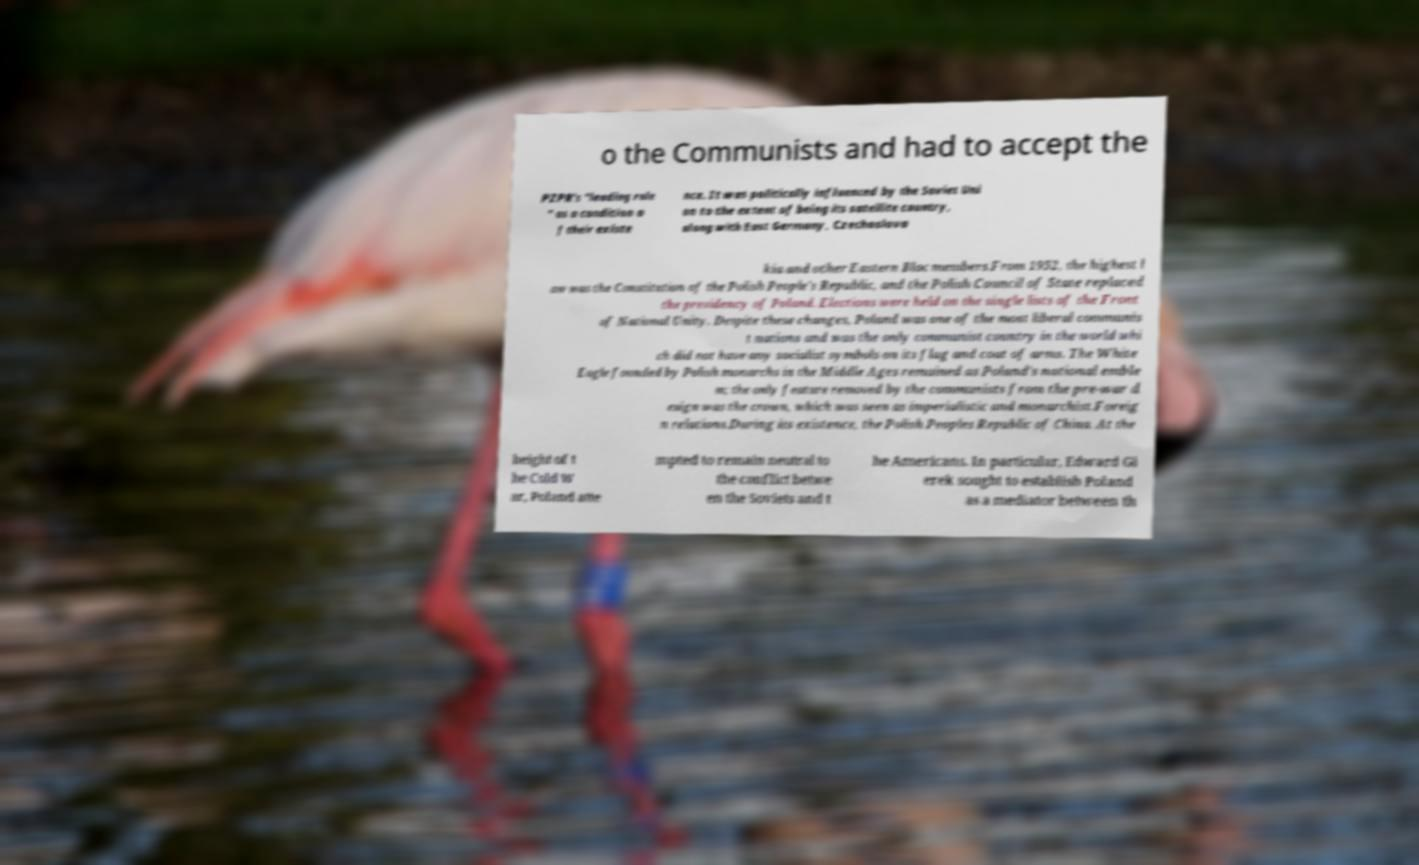Can you accurately transcribe the text from the provided image for me? o the Communists and had to accept the PZPR's "leading role " as a condition o f their existe nce. It was politically influenced by the Soviet Uni on to the extent of being its satellite country, along with East Germany, Czechoslova kia and other Eastern Bloc members.From 1952, the highest l aw was the Constitution of the Polish People's Republic, and the Polish Council of State replaced the presidency of Poland. Elections were held on the single lists of the Front of National Unity. Despite these changes, Poland was one of the most liberal communis t nations and was the only communist country in the world whi ch did not have any socialist symbols on its flag and coat of arms. The White Eagle founded by Polish monarchs in the Middle Ages remained as Poland's national emble m; the only feature removed by the communists from the pre-war d esign was the crown, which was seen as imperialistic and monarchist.Foreig n relations.During its existence, the Polish Peoples Republic of China. At the height of t he Cold W ar, Poland atte mpted to remain neutral to the conflict betwe en the Soviets and t he Americans. In particular, Edward Gi erek sought to establish Poland as a mediator between th 